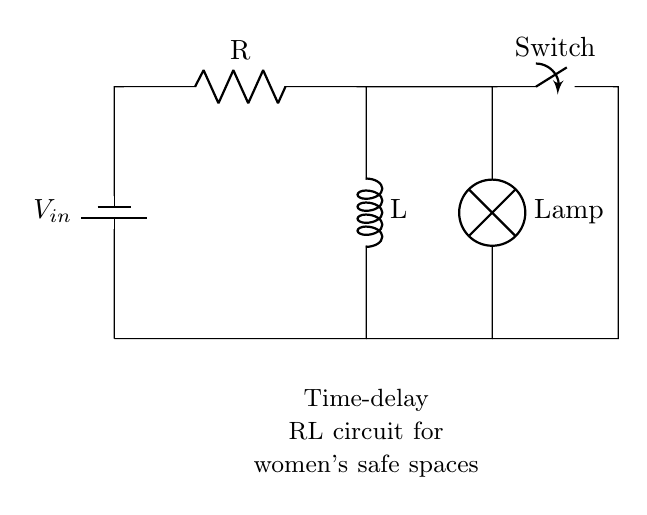What is the input voltage for this circuit? The input voltage is represented by the label \( V_{in} \) near the battery in the circuit diagram, indicating the source of electrical energy.
Answer: V in What are the main components in this circuit? The main components identified in the circuit diagram include a resistor, an inductor, a switch, and a lamp. Each component is clearly labeled, making them easy to identify.
Answer: Resistor, inductor, switch, lamp What is the function of the resistor in this circuit? The resistor's function in a circuit generally includes limiting current, dividing voltages, or producing heat. In this time-delay circuit, it helps to control the current flowing through the inductor, influencing the time delay for the lamp to turn on.
Answer: Current limiting What happens when the switch is closed? Closing the switch creates a closed loop allowing current to flow from the battery through the resistor and inductor to the lamp, which will eventually light up after a delay due to the inductor's properties.
Answer: Lamp lights up What is the role of the inductor in this circuit? The inductor stores energy in the magnetic field when current flows through it, and in this time-delay circuit, it creates a delay in the activation of the lamp by opposing changes in current.
Answer: Energy storage How will the time delay be affected if the resistor value increases? Increasing the resistor value will slow down the charging of the inductor and therefore increase the time delay before the lamp turns on, as the inductor takes longer to reach the current threshold needed to light the lamp.
Answer: Increases time delay What is the purpose of the lamp in this circuit? The lamp serves as the load that is activated by the circuit; when the current reaches the required level after the delay, the lamp turns on, serving to illuminate the area as desired.
Answer: Light output 